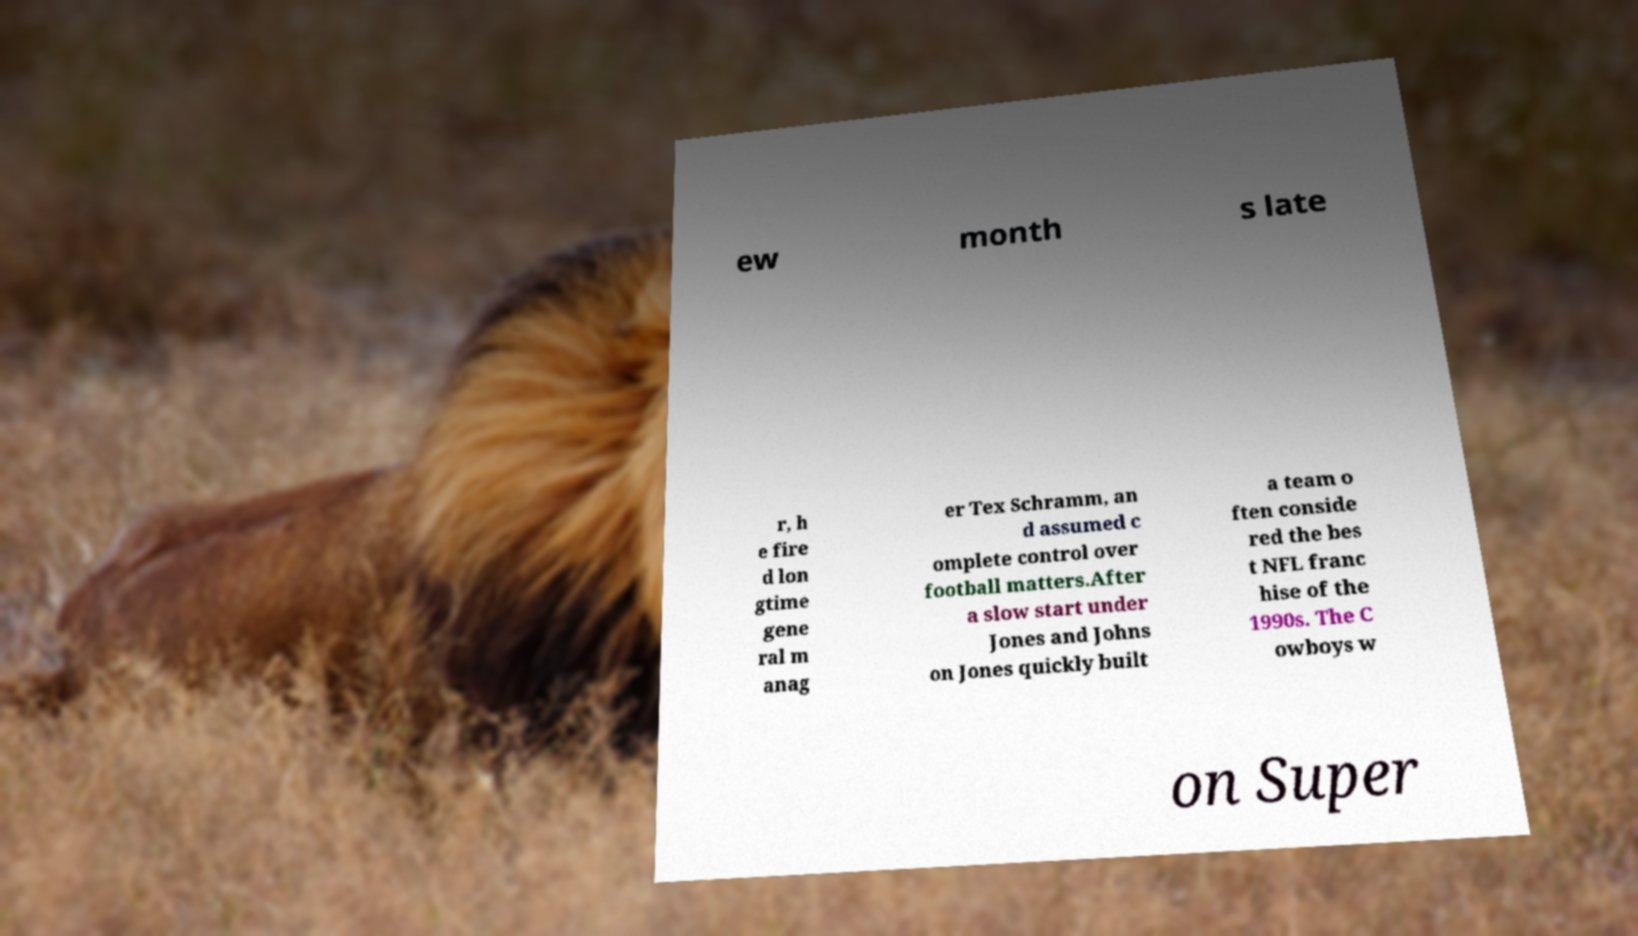Could you assist in decoding the text presented in this image and type it out clearly? ew month s late r, h e fire d lon gtime gene ral m anag er Tex Schramm, an d assumed c omplete control over football matters.After a slow start under Jones and Johns on Jones quickly built a team o ften conside red the bes t NFL franc hise of the 1990s. The C owboys w on Super 